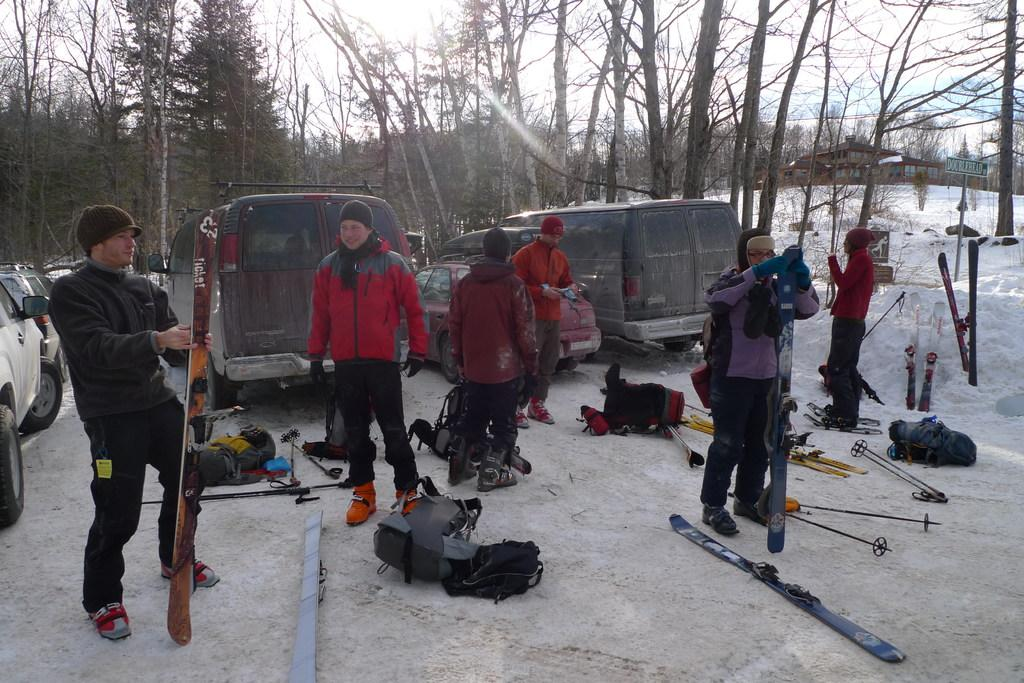How many persons can be seen in the image? There are persons standing in the image. What are the persons holding in the image? The persons are holding objects. What can be seen in the background of the image? The sky, clouds, trees, vehicles, and snow are visible in the background of the image. Are there any additional items present in the background of the image? Yes, backpacks are present in the background of the image. What type of oatmeal is being served to the minister in the image? There is no minister or oatmeal present in the image. 